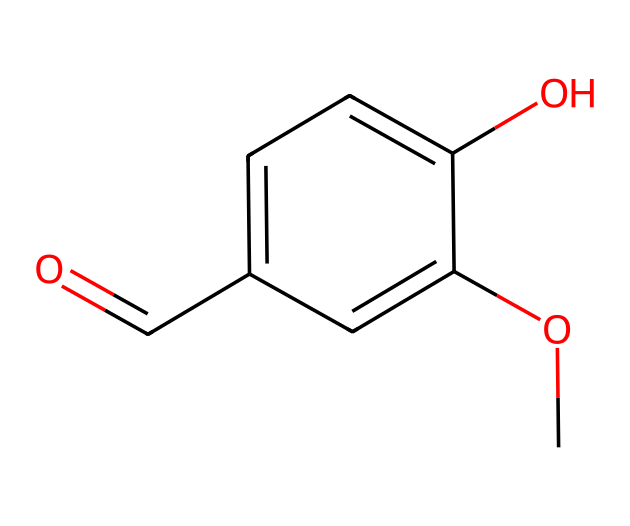How many chiral centers are in vanillin? Analyzing the structure, there is one carbon atom that has four different substituents attached to it, indicating a chiral center.
Answer: one What is the functional group present in vanillin? Observing the structure, the presence of the aldehyde group (–CHO) is identified. There is also a hydroxyl group (–OH) and a methoxy group (–OCH3).
Answer: aldehyde What is the molecular formula of vanillin? By counting the atoms in the structure from the SMILES representation, the total count gives C8H8O3, meaning there are 8 carbon atoms, 8 hydrogen atoms, and 3 oxygen atoms.
Answer: C8H8O3 Which substituent is responsible for the sweet aroma of vanillin? The aromatic ring, along with the aldehyde group, is responsible for the characteristic sweet aroma, which is a key aspect of its flavor profile.
Answer: aromatic ring Is vanillin a chiral compound? Since there is one chiral center in the structure, which gives rise to enantiomers, vanillin is categorized as a chiral compound.
Answer: yes What role does vanillin play in products? As a flavoring agent, particularly in food and perfumes, vanillin enhances sensory appeal by providing a vanilla taste and smell that attracts consumers.
Answer: flavoring agent 